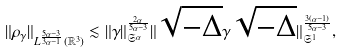<formula> <loc_0><loc_0><loc_500><loc_500>\| \rho _ { \gamma } \| _ { L ^ { \frac { 5 \alpha - 3 } { 3 \alpha - 1 } } ( \mathbb { R } ^ { 3 } ) } \lesssim \| \gamma \| _ { \mathfrak { S } ^ { \alpha } } ^ { \frac { 2 \alpha } { 5 \alpha - 3 } } \| \sqrt { - \Delta } \gamma \sqrt { - \Delta } \| _ { \mathfrak { S } ^ { 1 } } ^ { \frac { 3 ( \alpha - 1 ) } { 5 \alpha - 3 } } ,</formula> 